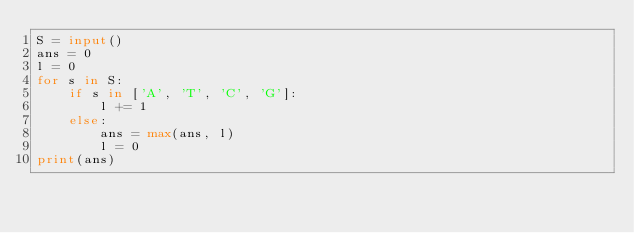<code> <loc_0><loc_0><loc_500><loc_500><_Python_>S = input()
ans = 0
l = 0
for s in S:
    if s in ['A', 'T', 'C', 'G']:
        l += 1
    else:
        ans = max(ans, l)
        l = 0
print(ans)</code> 